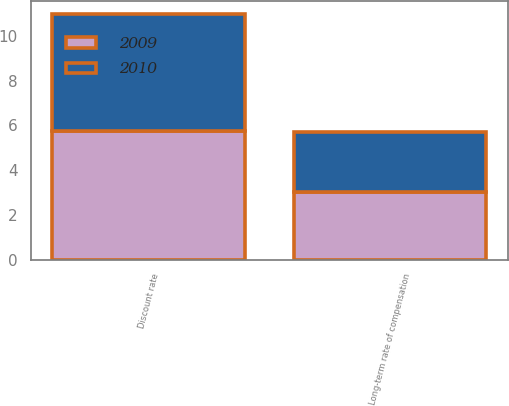Convert chart to OTSL. <chart><loc_0><loc_0><loc_500><loc_500><stacked_bar_chart><ecel><fcel>Discount rate<fcel>Long-term rate of compensation<nl><fcel>2010<fcel>5.25<fcel>2.7<nl><fcel>2009<fcel>5.75<fcel>3<nl></chart> 